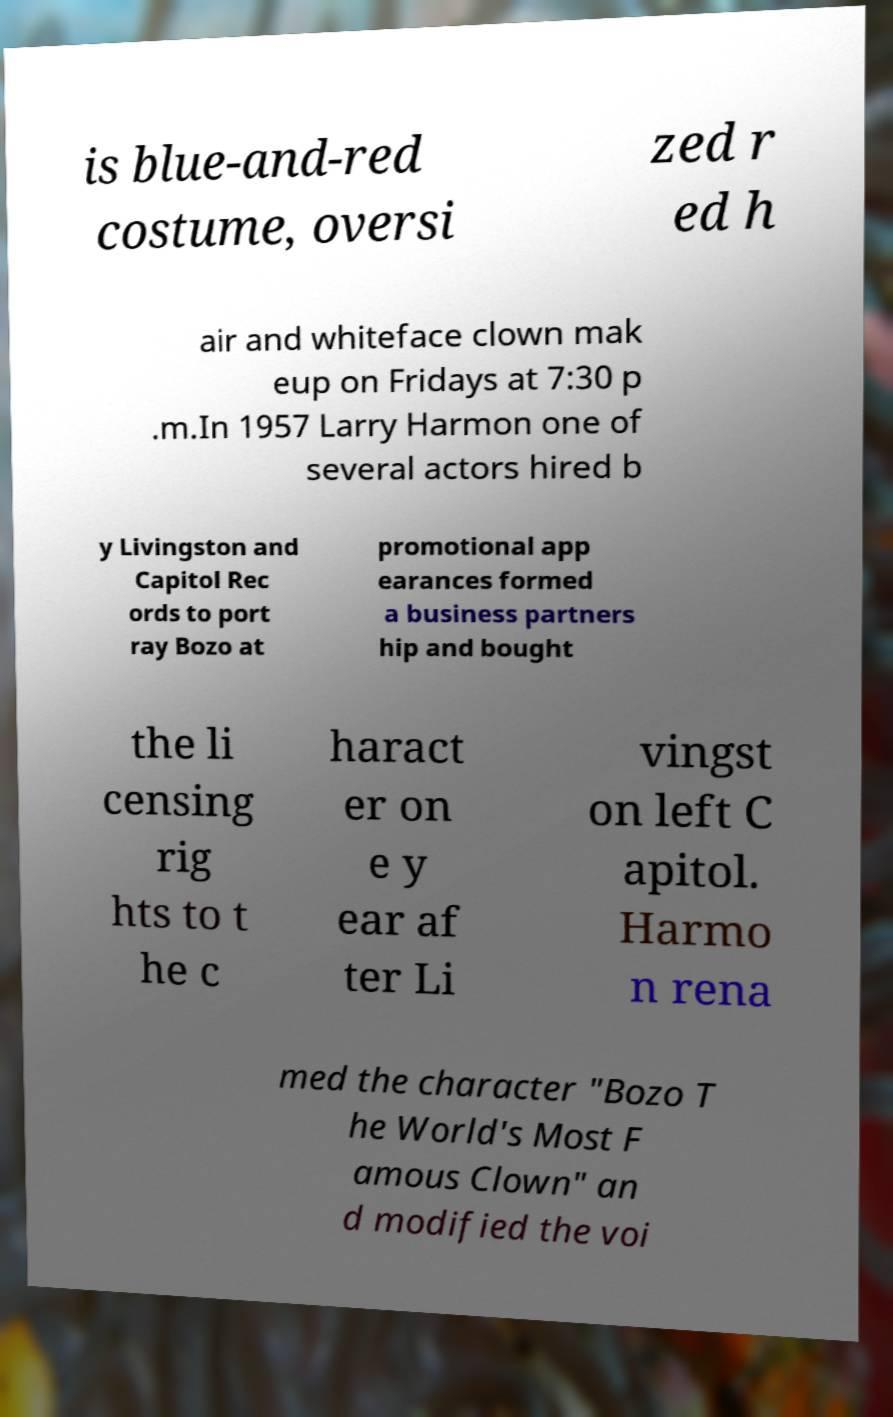What messages or text are displayed in this image? I need them in a readable, typed format. is blue-and-red costume, oversi zed r ed h air and whiteface clown mak eup on Fridays at 7:30 p .m.In 1957 Larry Harmon one of several actors hired b y Livingston and Capitol Rec ords to port ray Bozo at promotional app earances formed a business partners hip and bought the li censing rig hts to t he c haract er on e y ear af ter Li vingst on left C apitol. Harmo n rena med the character "Bozo T he World's Most F amous Clown" an d modified the voi 